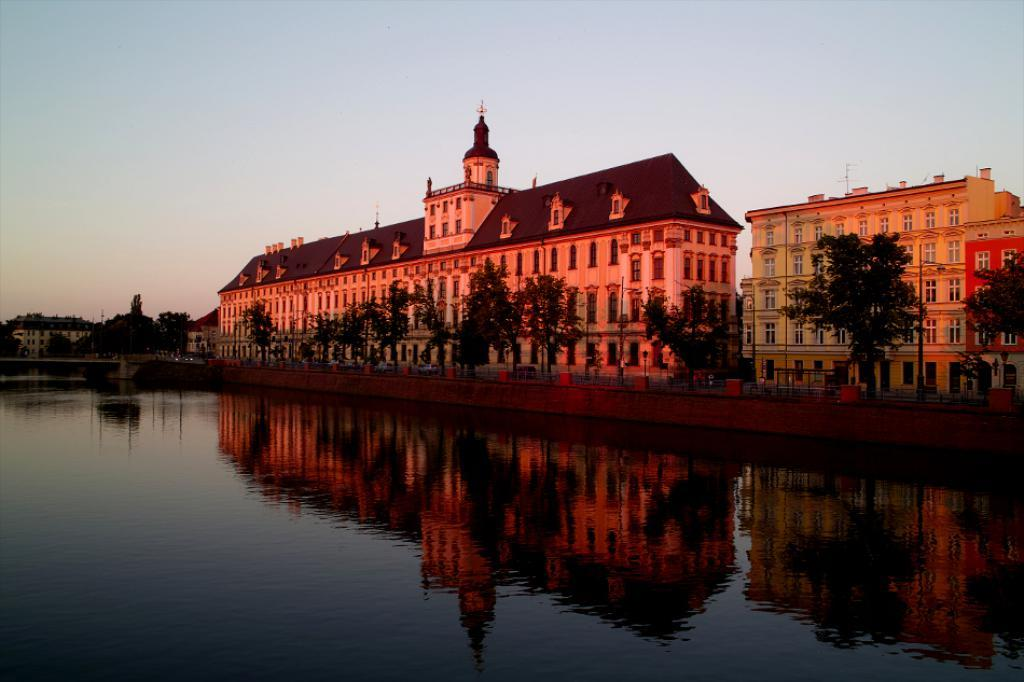What is located in the center of the image? There are buildings, trees, poles, and fencing in the center of the image. What feature do the buildings have? The buildings have windows. What type of vegetation is present in the center of the image? There are trees in the center of the image. What other structures can be seen in the center of the image? There are poles in the center of the image. What type of barrier is present in the center of the image? There is fencing in the center of the image. What is visible at the top of the image? The sky is visible at the top of the image. What is visible at the bottom of the image? Water is visible at the bottom of the image. What type of drum is being played in the image? There is no drum present in the image. What type of trade is being conducted in the image? There is no trade being conducted in the image. 